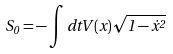Convert formula to latex. <formula><loc_0><loc_0><loc_500><loc_500>S _ { 0 } = - \int d t V ( x ) \sqrt { 1 - { \dot { x } } ^ { 2 } }</formula> 